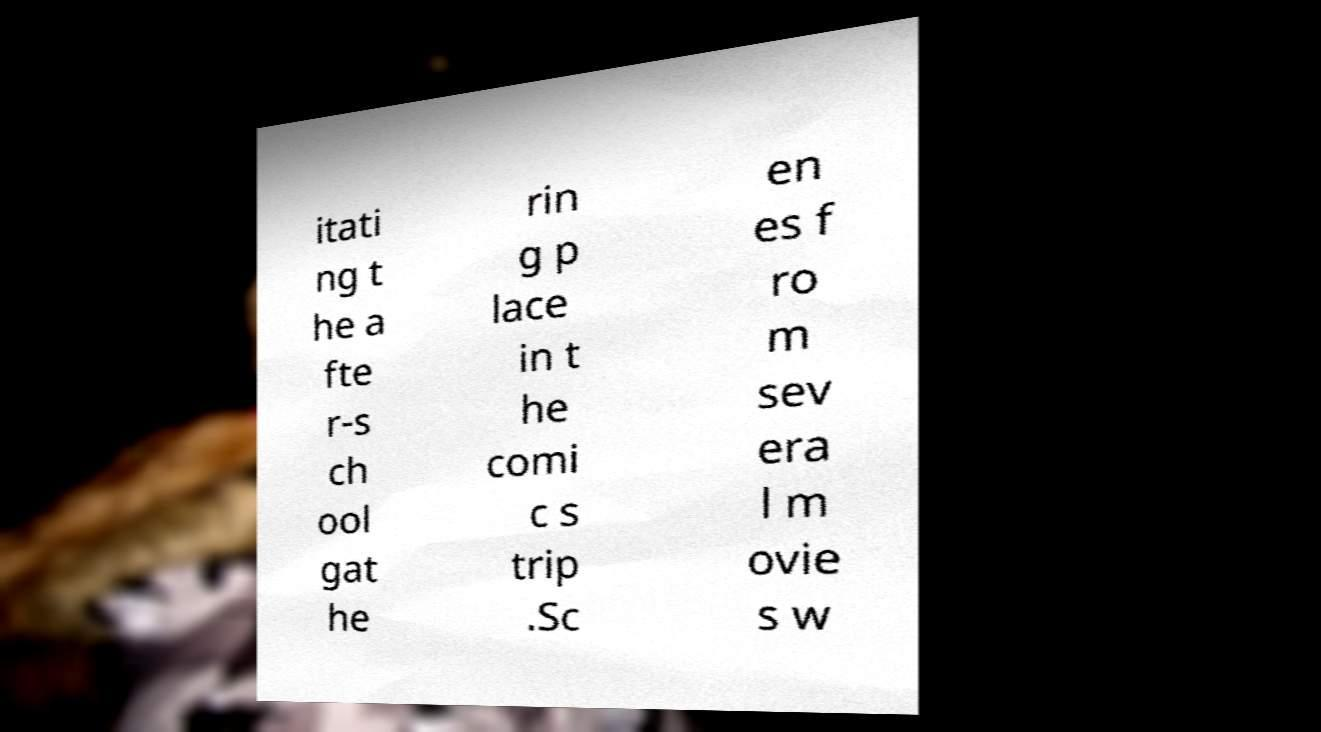I need the written content from this picture converted into text. Can you do that? itati ng t he a fte r-s ch ool gat he rin g p lace in t he comi c s trip .Sc en es f ro m sev era l m ovie s w 